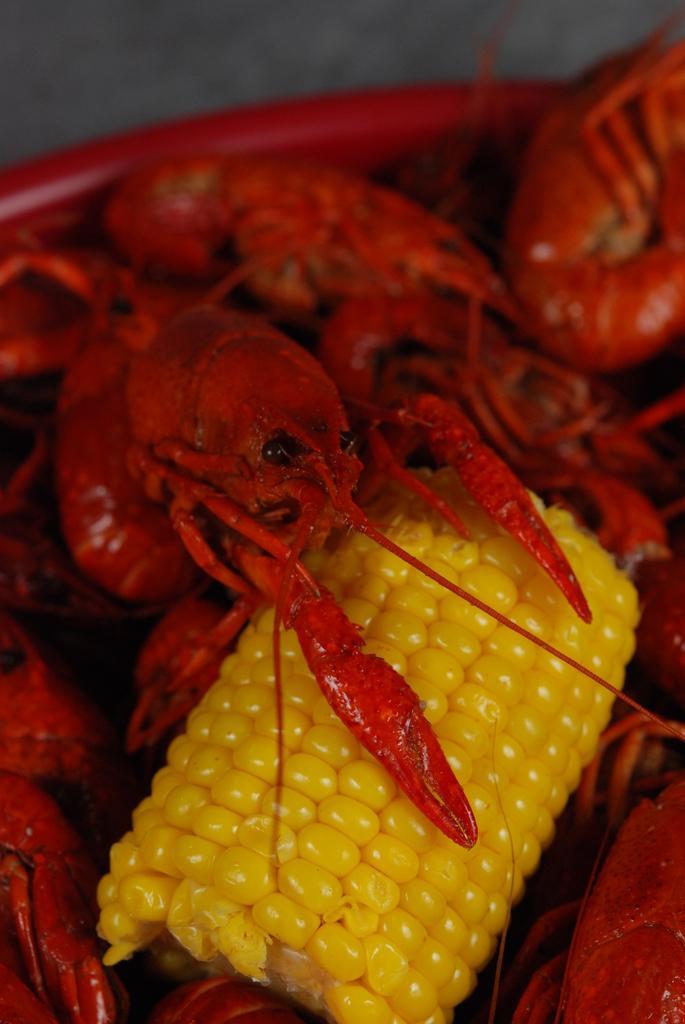How would you summarize this image in a sentence or two? In this image I can see a red colored bowl and in the bowl I can see a corn which is yellow in color and few prawns which are red and black in color. 